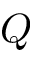<formula> <loc_0><loc_0><loc_500><loc_500>Q</formula> 